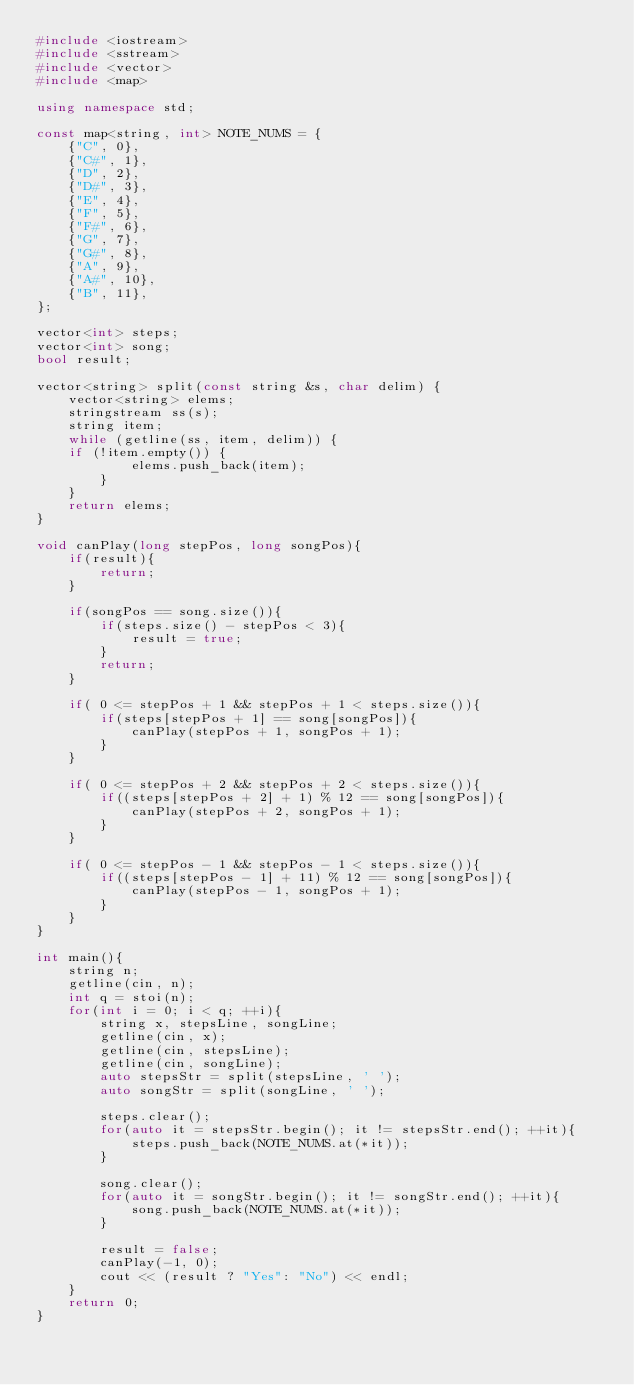Convert code to text. <code><loc_0><loc_0><loc_500><loc_500><_C++_>#include <iostream>
#include <sstream>
#include <vector>
#include <map>

using namespace std;

const map<string, int> NOTE_NUMS = {
    {"C", 0},
    {"C#", 1},
    {"D", 2},
    {"D#", 3},
    {"E", 4},
    {"F", 5},
    {"F#", 6},
    {"G", 7},
    {"G#", 8},
    {"A", 9},
    {"A#", 10},
    {"B", 11},
};

vector<int> steps;
vector<int> song;
bool result;

vector<string> split(const string &s, char delim) {
    vector<string> elems;
    stringstream ss(s);
    string item;
    while (getline(ss, item, delim)) {
    if (!item.empty()) {
            elems.push_back(item);
        }
    }
    return elems;
}

void canPlay(long stepPos, long songPos){
    if(result){
        return;
    }

    if(songPos == song.size()){
        if(steps.size() - stepPos < 3){
            result = true;
        }
        return;
    }

    if( 0 <= stepPos + 1 && stepPos + 1 < steps.size()){
        if(steps[stepPos + 1] == song[songPos]){
            canPlay(stepPos + 1, songPos + 1);
        }
    }

    if( 0 <= stepPos + 2 && stepPos + 2 < steps.size()){
        if((steps[stepPos + 2] + 1) % 12 == song[songPos]){
            canPlay(stepPos + 2, songPos + 1);
        }
    }

    if( 0 <= stepPos - 1 && stepPos - 1 < steps.size()){
        if((steps[stepPos - 1] + 11) % 12 == song[songPos]){
            canPlay(stepPos - 1, songPos + 1);
        }
    }
}

int main(){
    string n;
    getline(cin, n);
    int q = stoi(n);
    for(int i = 0; i < q; ++i){
        string x, stepsLine, songLine;
        getline(cin, x);
        getline(cin, stepsLine);
        getline(cin, songLine);
        auto stepsStr = split(stepsLine, ' ');
        auto songStr = split(songLine, ' ');

        steps.clear();
        for(auto it = stepsStr.begin(); it != stepsStr.end(); ++it){
            steps.push_back(NOTE_NUMS.at(*it));
        }

        song.clear();
        for(auto it = songStr.begin(); it != songStr.end(); ++it){
            song.push_back(NOTE_NUMS.at(*it));
        }

        result = false;
        canPlay(-1, 0);
        cout << (result ? "Yes": "No") << endl;
    }
    return 0;
}

</code> 